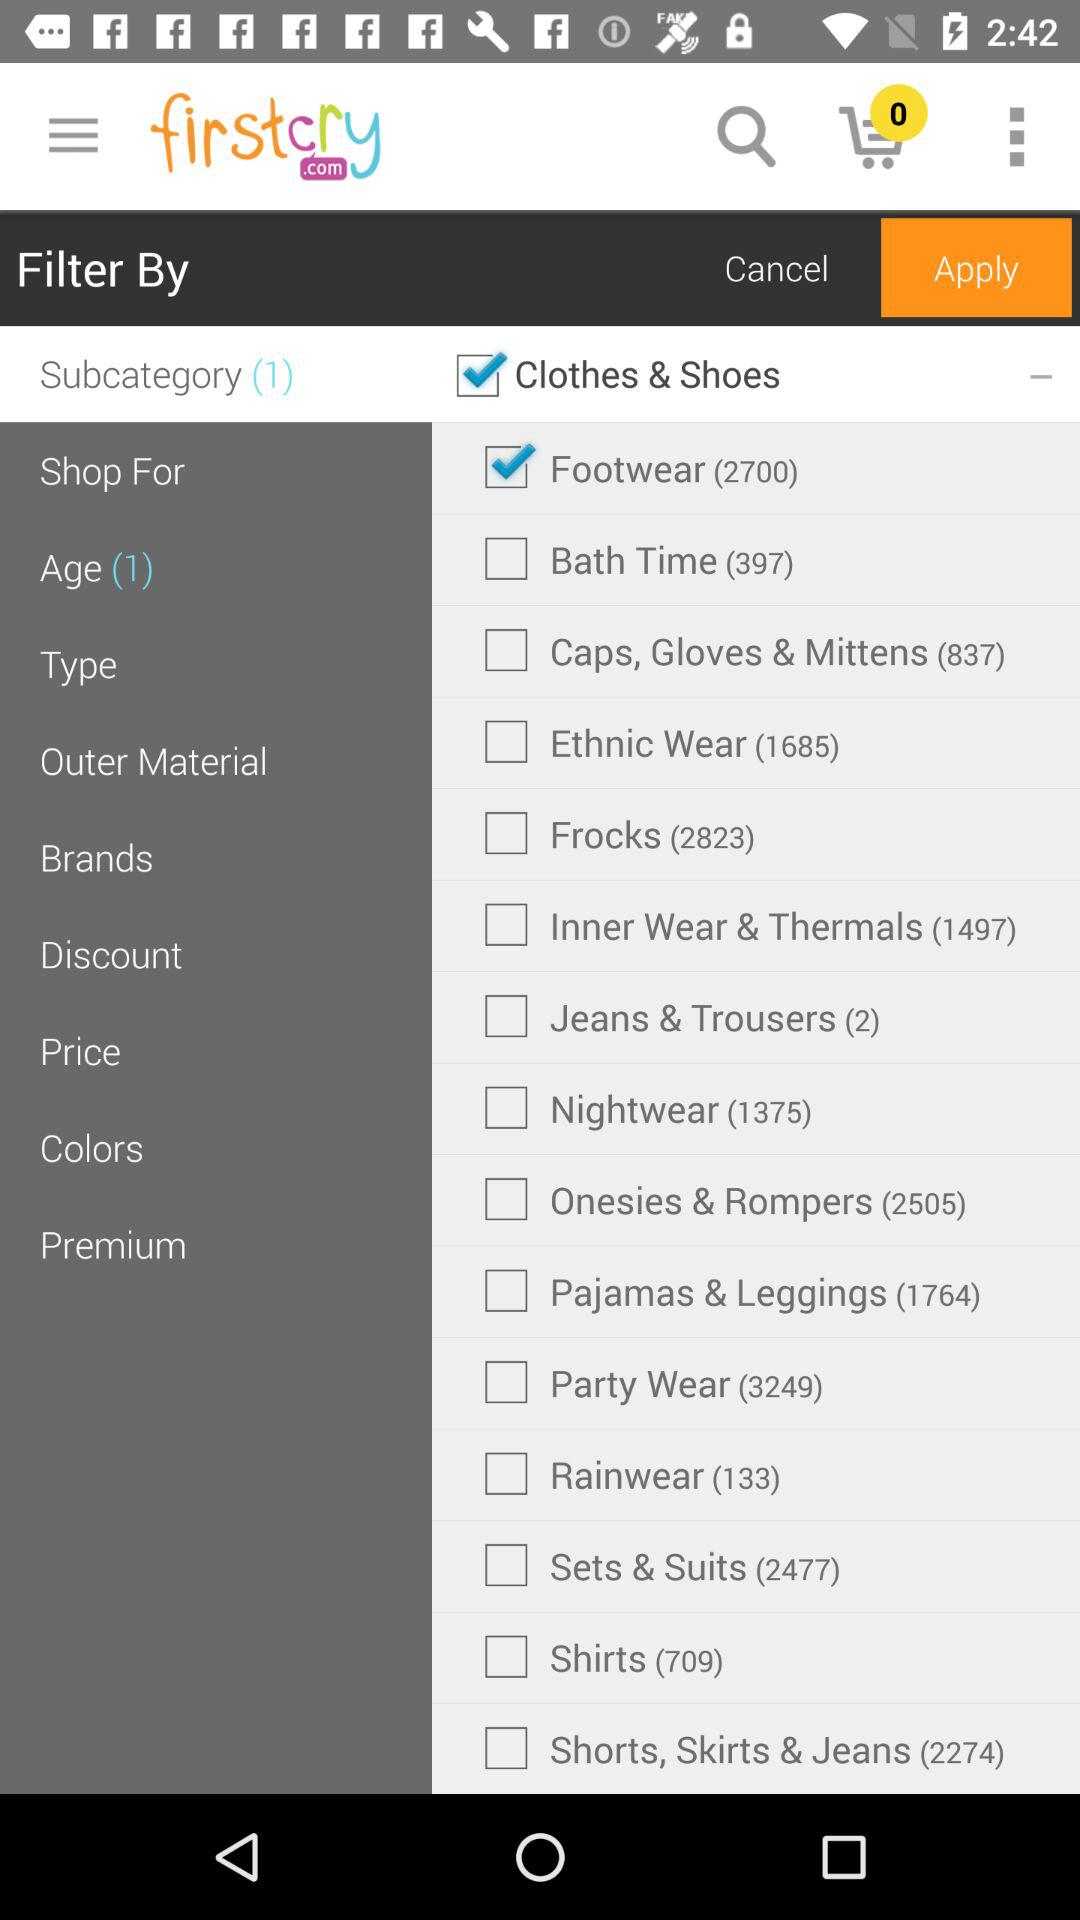How many items are in the footwear category? There are 2700 items in the footwear category. 